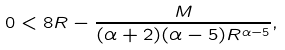Convert formula to latex. <formula><loc_0><loc_0><loc_500><loc_500>0 < 8 R - \frac { M } { ( \alpha + 2 ) ( \alpha - 5 ) R ^ { \alpha - 5 } } ,</formula> 